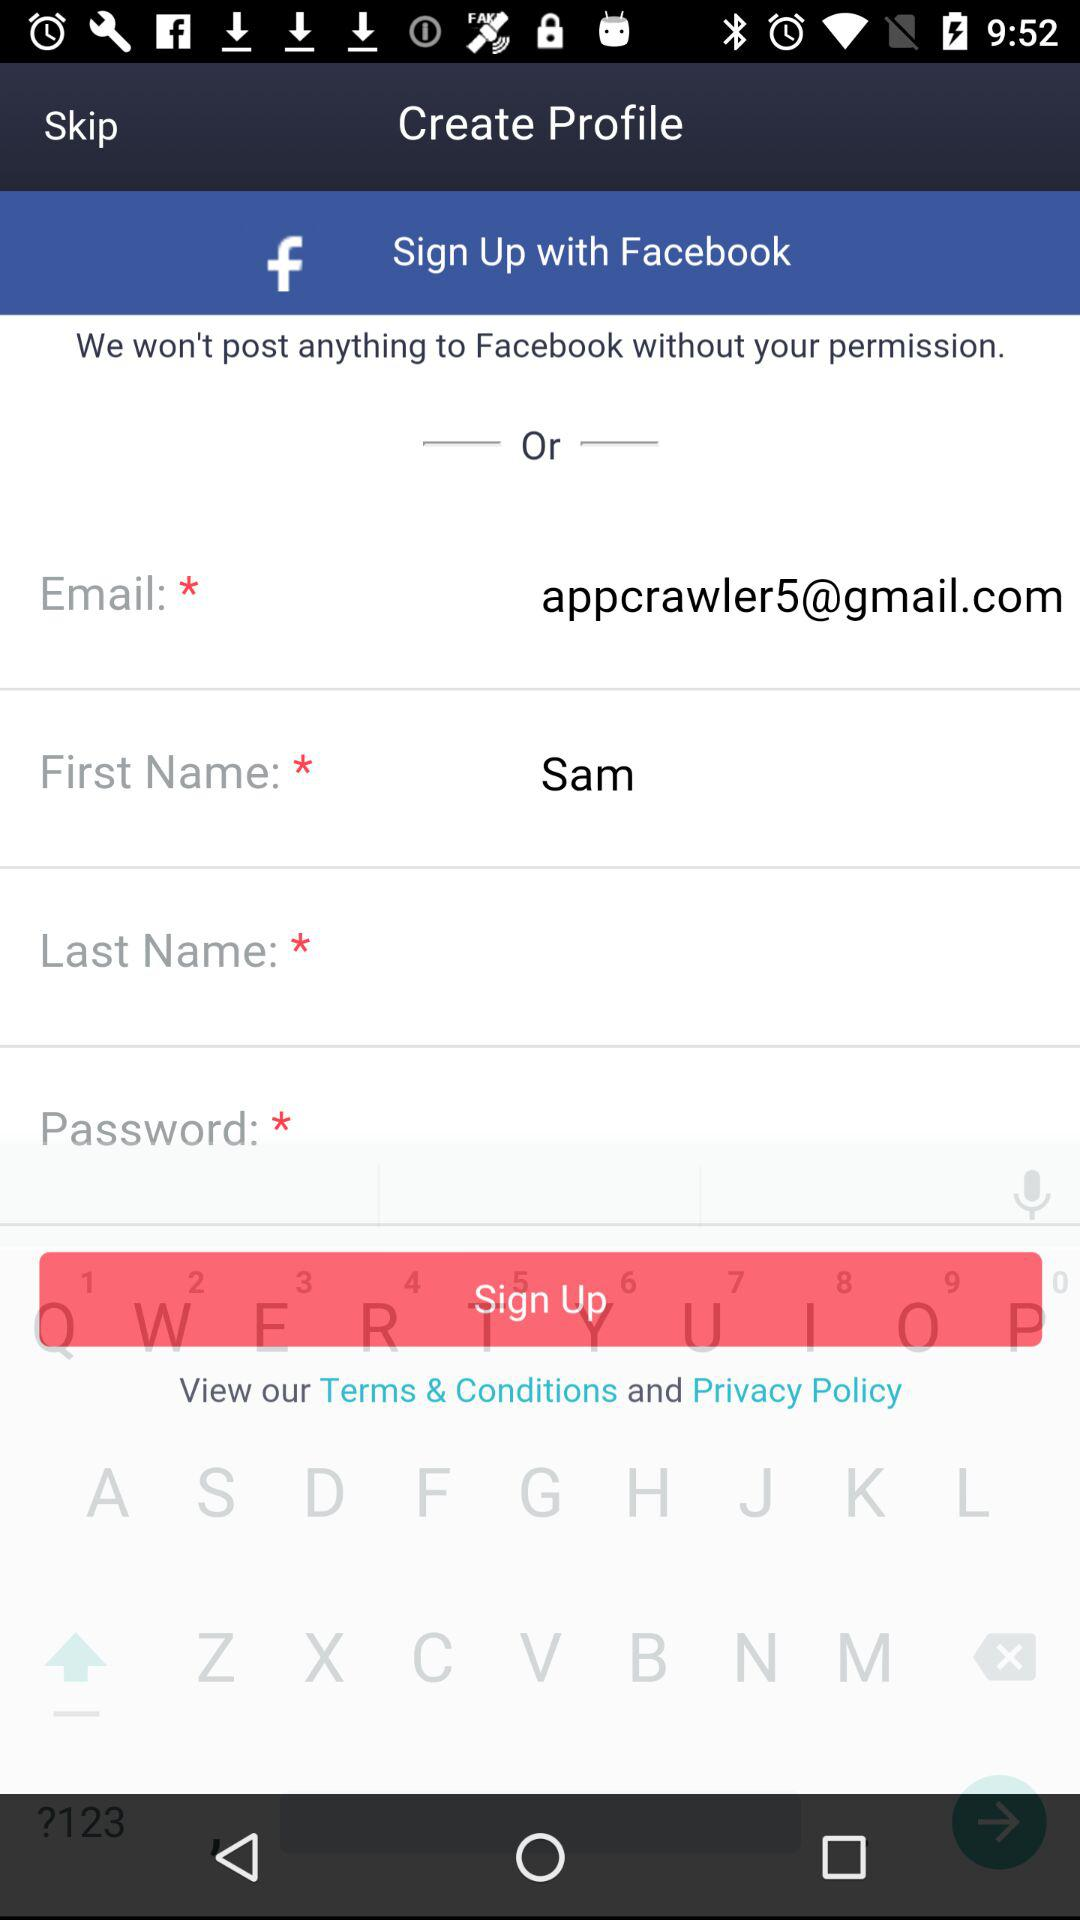What is the first name? The first name is Sam. 